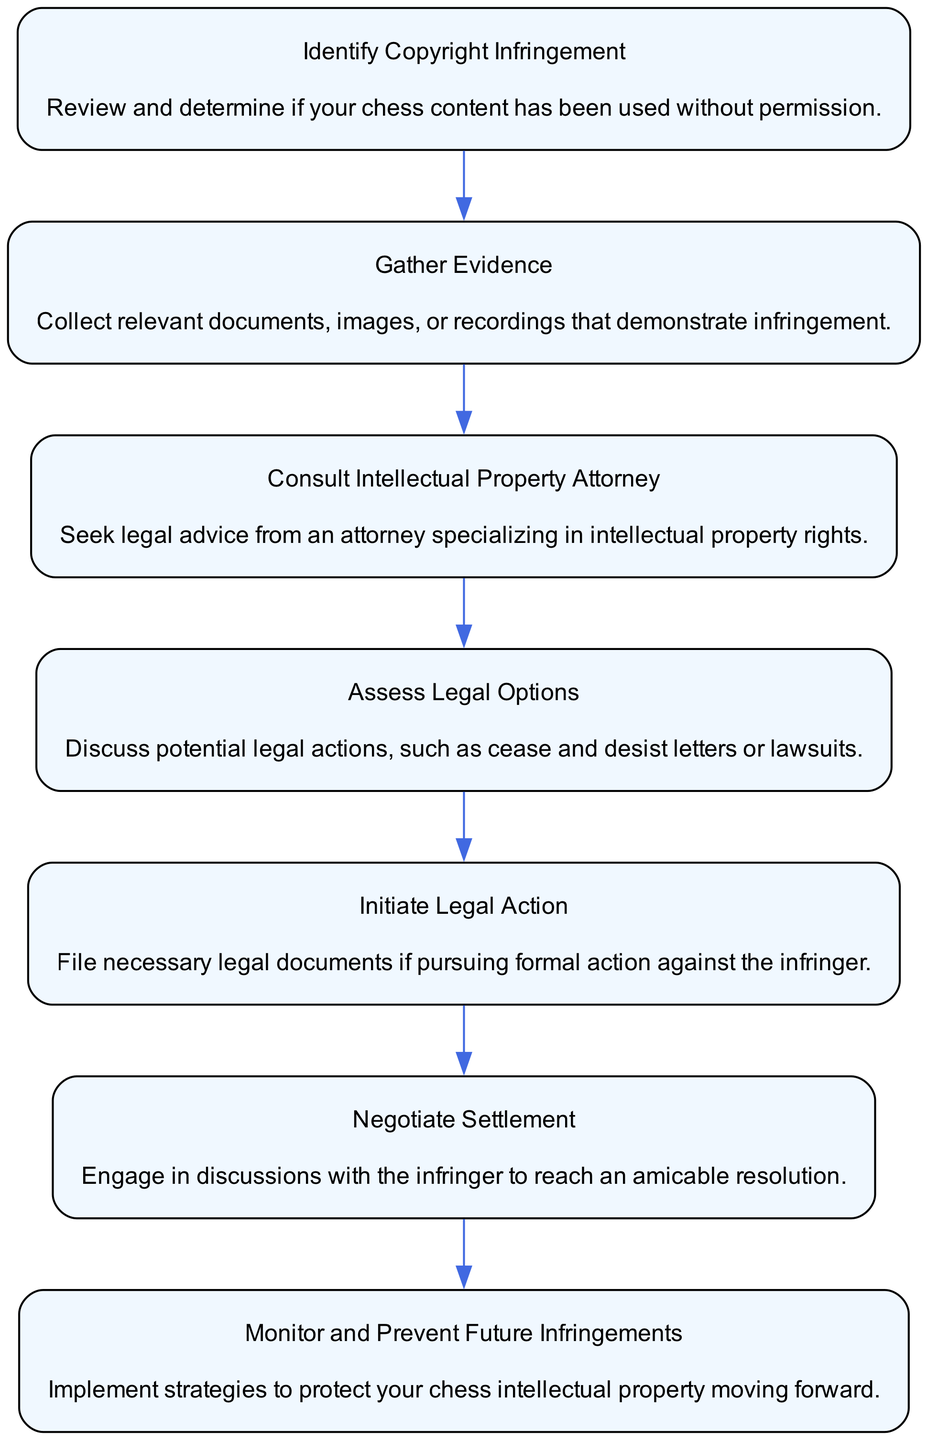What is the first step in the flow chart? The first step in the flow chart is labeled "Identify Copyright Infringement." This is identified as the starting point of the process where one reviews their chess content for unauthorized use.
Answer: Identify Copyright Infringement How many total steps are presented in the diagram? There are seven nodes or steps presented in the diagram, each representing a distinct action or consideration in the flow of legal consultation.
Answer: 7 What follows "Gather Evidence" in the flow? After "Gather Evidence," the next step is "Consult Intellectual Property Attorney." This shows the progression from collecting evidence to seeking legal guidance.
Answer: Consult Intellectual Property Attorney What action is taken after assessing legal options? After "Assess Legal Options," the action taken is "Initiate Legal Action." This indicates the flow of moving from evaluation to actual legal proceedings.
Answer: Initiate Legal Action Which node emphasizes preventing future infringements? The final node in the flow, "Monitor and Prevent Future Infringements," focuses on ongoing protection measures for intellectual property.
Answer: Monitor and Prevent Future Infringements How are "Negotiate Settlement" and "Initiate Legal Action" related? "Negotiate Settlement" occurs after assessing legal options before "Initiate Legal Action." This indicates an approach to resolving issues before resorting to formal proceedings.
Answer: Before What is the overall primary objective of this flow chart? The primary objective of the flow chart is to outline the steps necessary for consulting on chess-related copyright infringement, illustrating the progression from identifying issues to legal resolution.
Answer: Legal consultation for copyright infringement In how many steps does the process end? The process ends after the seventh step, which is about monitoring and preventing future infringements after legal actions.
Answer: 1 step What element of the flow involves collecting documents? The element "Gather Evidence" involves collecting relevant documents, images, or recordings that substantiate the claim of copyright infringement.
Answer: Gather Evidence 